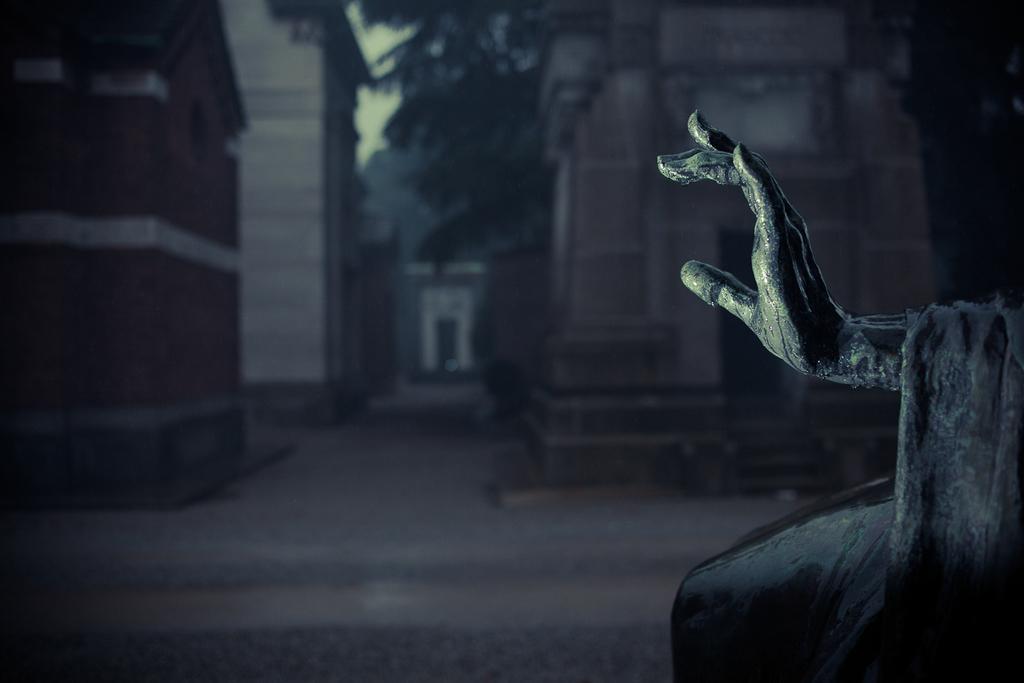Could you give a brief overview of what you see in this image? In this black and white image I can see the hand of a statue on the right hand side of the image with a blurred background. I can see some buildings and trees. 